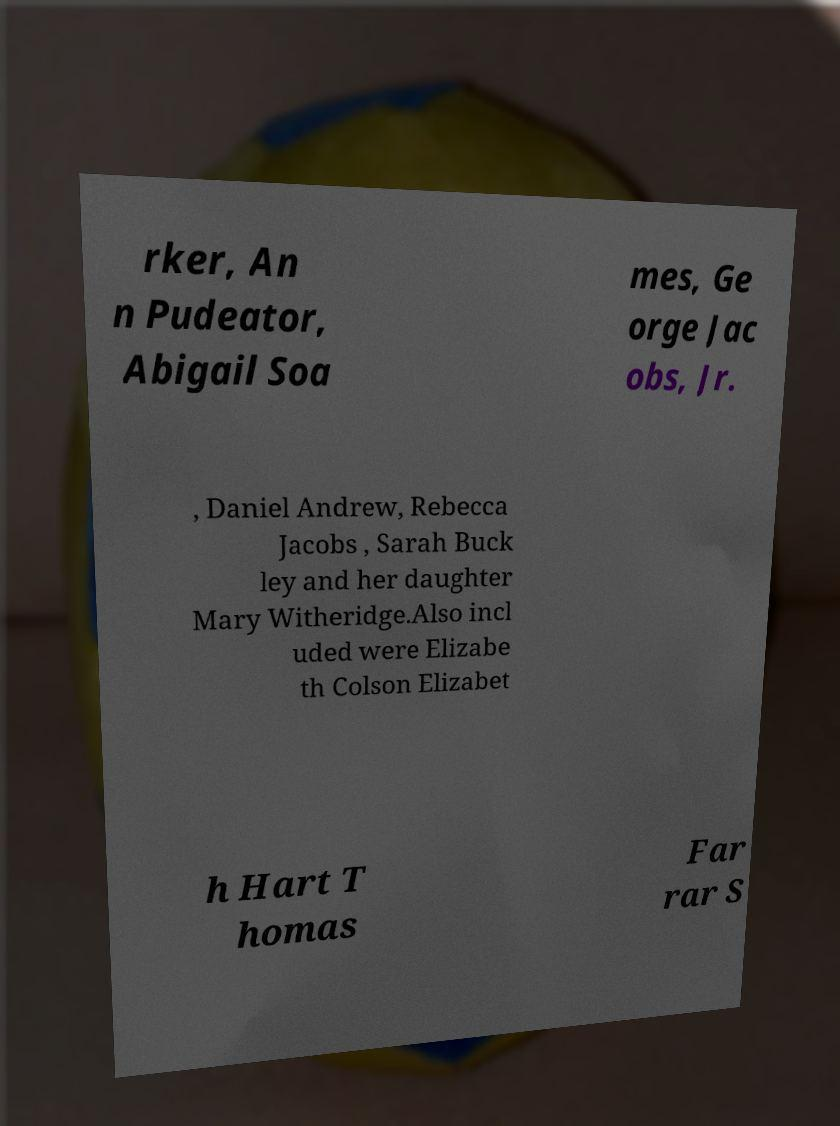Please read and relay the text visible in this image. What does it say? rker, An n Pudeator, Abigail Soa mes, Ge orge Jac obs, Jr. , Daniel Andrew, Rebecca Jacobs , Sarah Buck ley and her daughter Mary Witheridge.Also incl uded were Elizabe th Colson Elizabet h Hart T homas Far rar S 